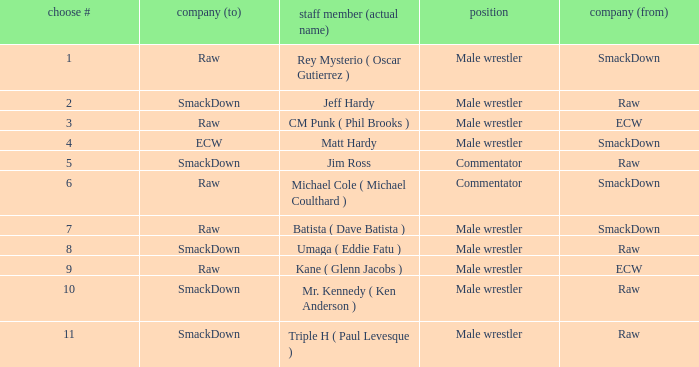What is the real name of the male wrestler from Raw with a pick # smaller than 6? Jeff Hardy. 